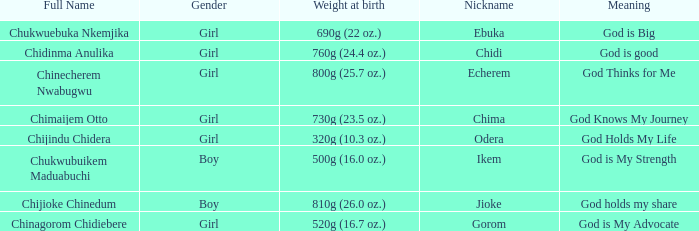How much did the baby who name means God knows my journey weigh at birth? 730g (23.5 oz.). 